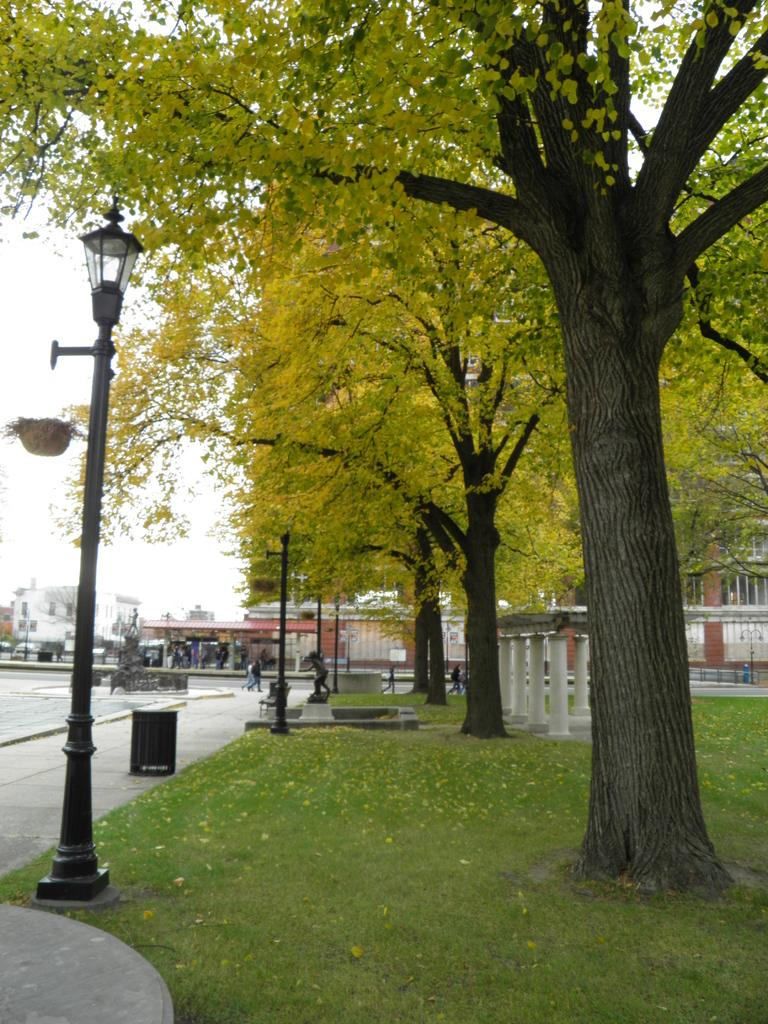What type of landscape is depicted in the image? There is a grassland in the image. What structures are present in the grassland? There are light poles in the image. What type of surface is visible in the image? There is a pavement in the image. What can be seen in the background of the image? There are trees, buildings, and the sky visible in the background of the image. What type of vase is placed on the edge of the pavement in the image? There is no vase present in the image; it only features a grassland, light poles, pavement, trees, buildings, and the sky. 